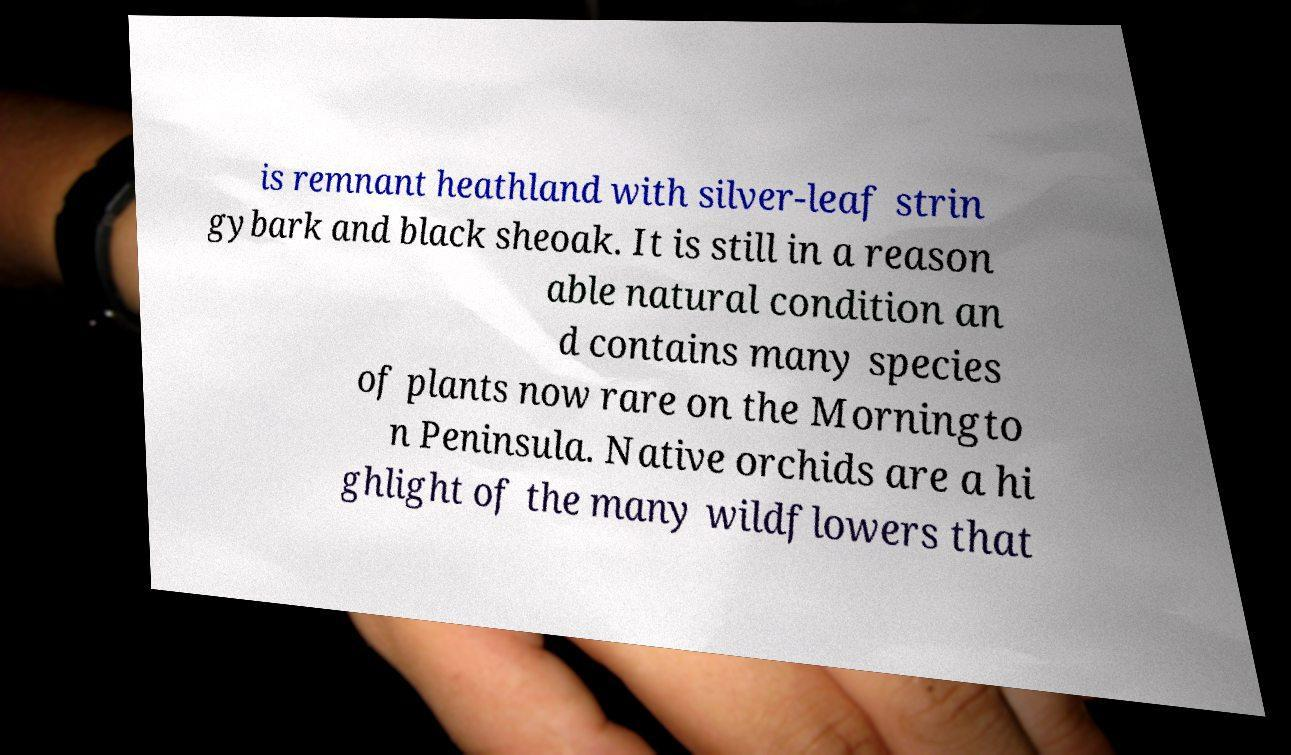For documentation purposes, I need the text within this image transcribed. Could you provide that? is remnant heathland with silver-leaf strin gybark and black sheoak. It is still in a reason able natural condition an d contains many species of plants now rare on the Morningto n Peninsula. Native orchids are a hi ghlight of the many wildflowers that 